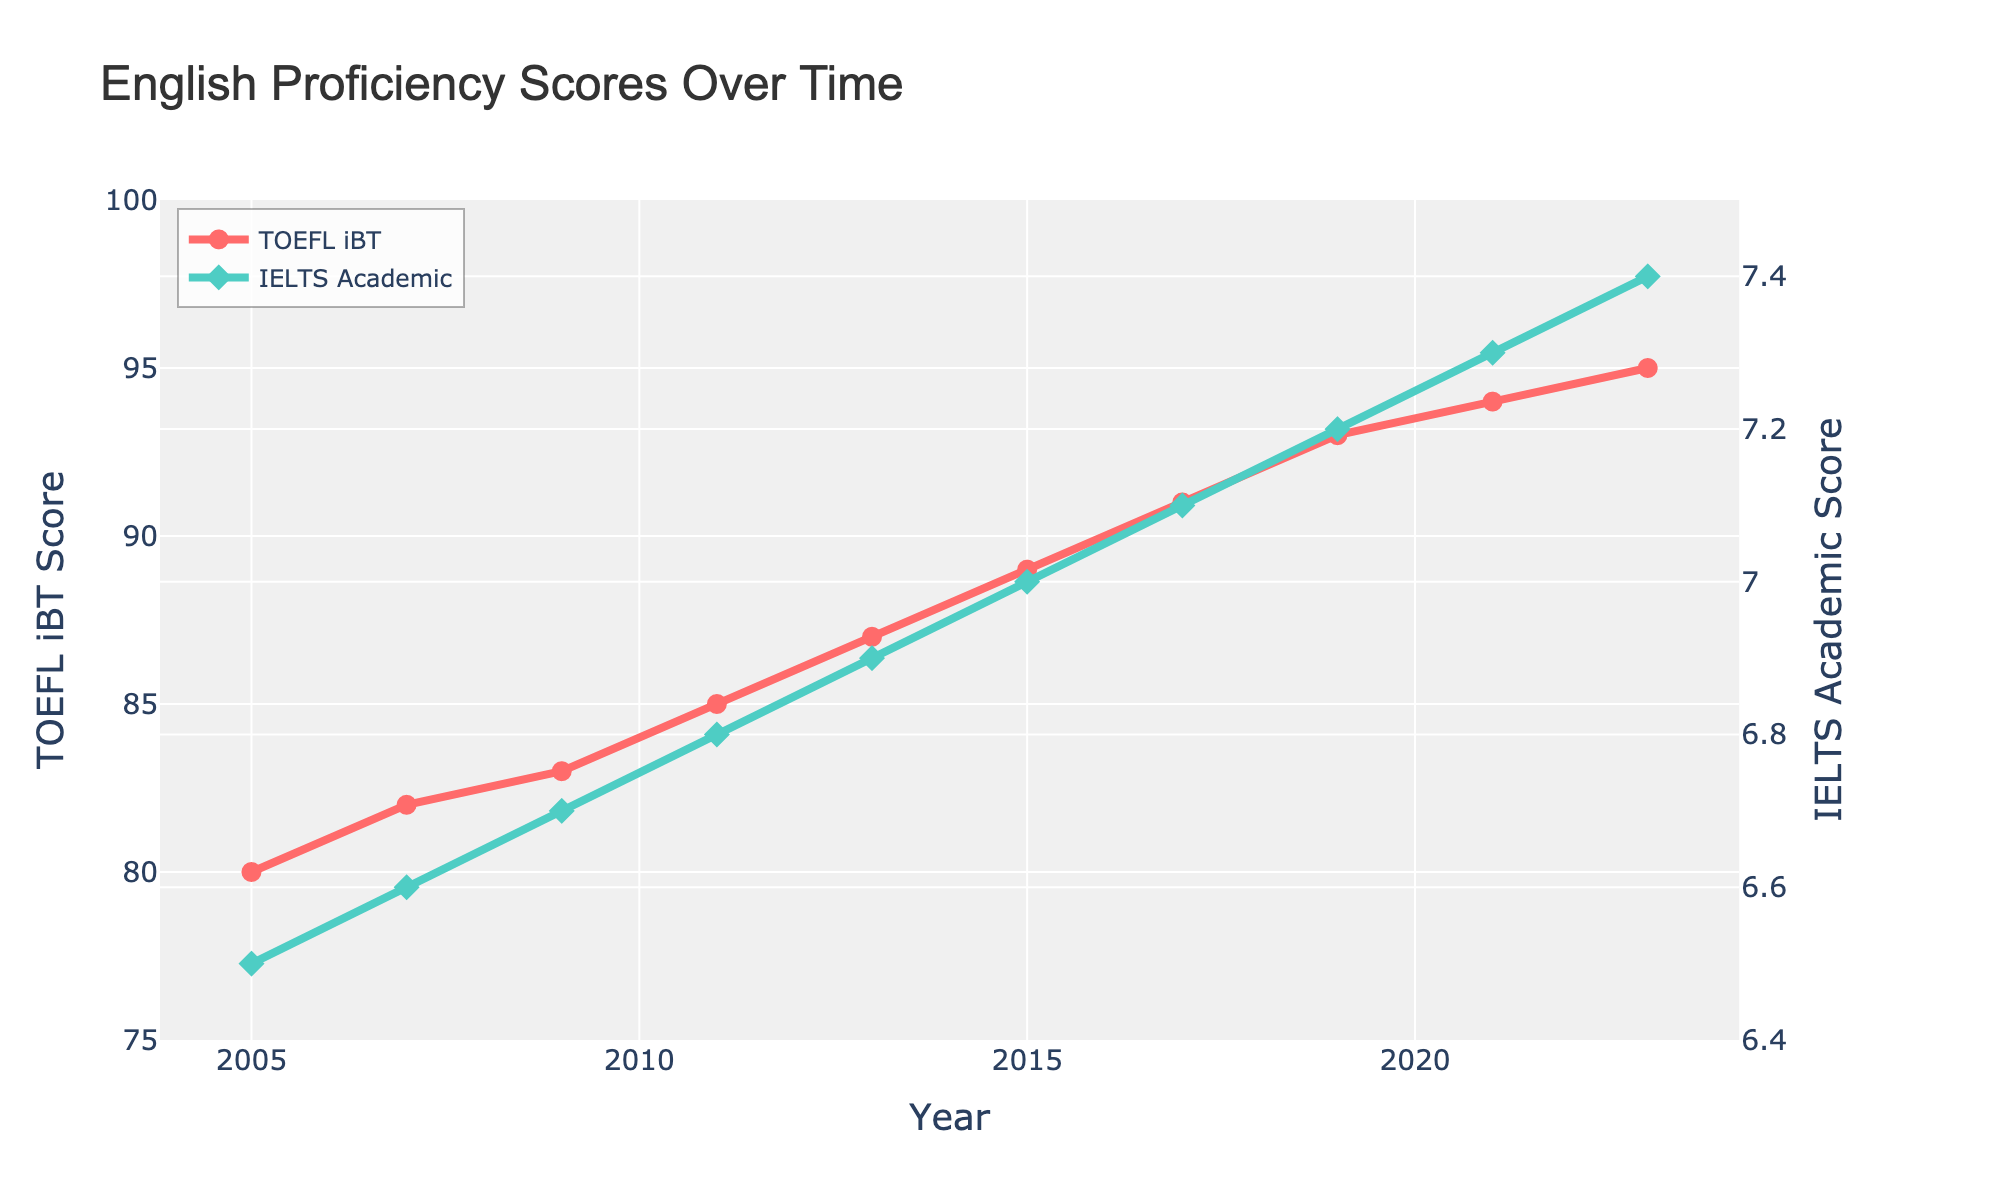What is the overall trend of TOEFL iBT scores from 2005 to 2023? The line for TOEFL iBT scores consistently increases from 80 in 2005 to 95 in 2023. This indicates an upward trend over the years.
Answer: Upward trend What is the difference in IELTS Academic scores between the years 2011 and 2019? The IELTS Academic score is 6.8 in 2011 and 7.2 in 2019. The difference is calculated as 7.2 - 6.8 = 0.4.
Answer: 0.4 Which year shows the highest improvement in TOEFL iBT scores compared to the previous year? The differences are: 2007-2005 (2), 2009-2007 (1), 2011-2009 (2), 2013-2011 (2), 2015-2013 (2), 2017-2015 (2), 2019-2017 (2), 2021-2019 (1), 2023-2021 (1). The highest improvement is 2 points which happens multiple times.
Answer: 2007, 2011, 2013, 2015, 2017 Which score, TOEFL iBT or IELTS Academic, shows a greater increase from 2005 to 2023? The TOEFL iBT score increased from 80 to 95 (15 points), and the IELTS Academic score increased from 6.5 to 7.4 (0.9 points). Since TOEFL iBT is on a different scale, we need to consider proportional change. Proportionally, TOEFL iBT increased by 15/80 = 18.75%, and IELTS increased by 0.9/6.5 ≈ 13.85%.
Answer: TOEFL iBT What is the TOEFL iBT score in 2015? By referring to the data points on the figure, the TOEFL iBT score in 2015 is given as 89.
Answer: 89 How much did the IELTS Academic score change between 2019 and 2023? The IELTS Academic score in 2019 is 7.2, and in 2023 it is 7.4. The change is calculated as 7.4 - 7.2 = 0.2.
Answer: 0.2 Which color represents the IELTS Academic score line? The IELTS Academic score line is shown in green, as observed from the figure.
Answer: Green What year did the IELTS Academic score first reach 7.0? The IELTS Academic score reaches 7.0 in the year 2015 according to the plotted data.
Answer: 2015 What is the average TOEFL iBT score between 2005 and 2015? Sum of TOEFL iBT scores from 2005 to 2015 is 80 + 82 + 83 + 85 + 87 + 89 = 506. The number of years is 6. Therefore, the average score is 506/6 ≈ 84.33.
Answer: 84.33 In which year do the TOEFL iBT and IELTS Academic scores seem to have the smallest gap according to the figure? By visually inspecting the figure, the smallest gap between the TOEFL iBT and IELTS Academic scores appears around the year 2005 as both scores are relatively close compared to the other years.
Answer: 2005 